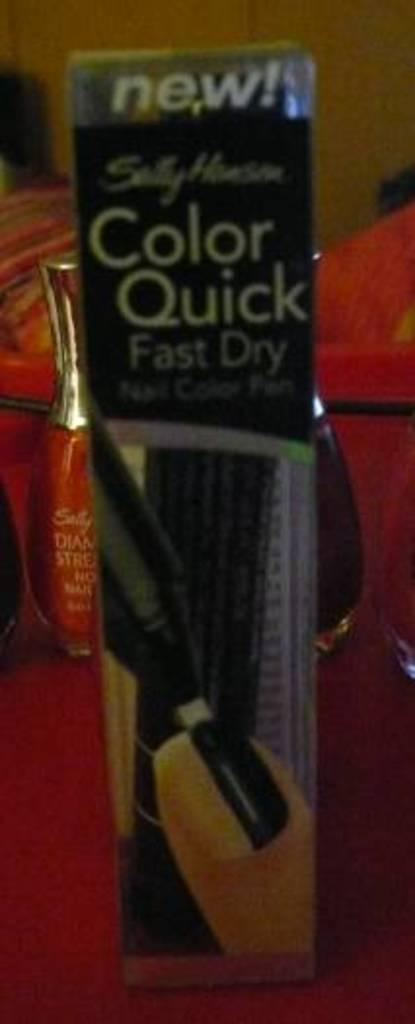<image>
Summarize the visual content of the image. a Sally Hansen Color Quick nail polish pen in its packaging 